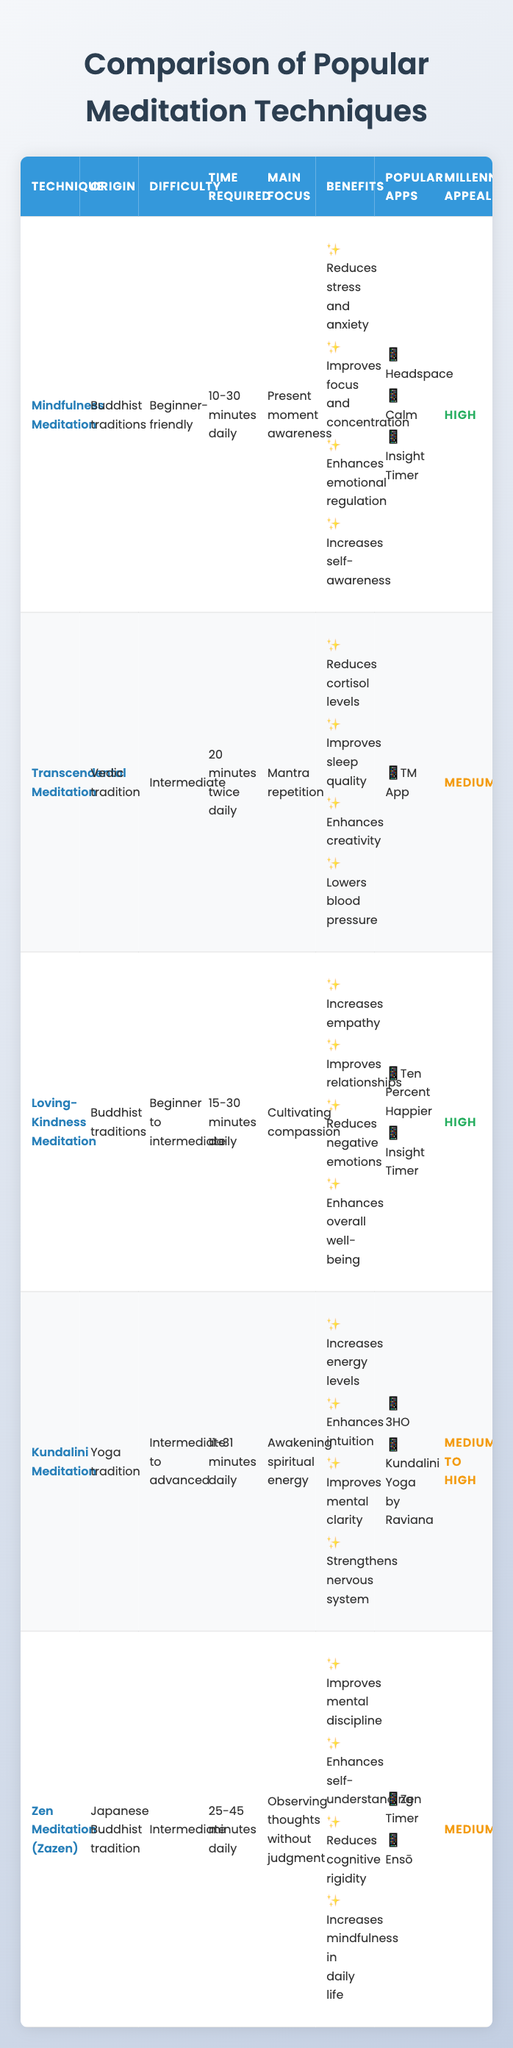What is the main focus of Zen Meditation? According to the table, Zen Meditation's main focus is observing thoughts without judgment. This information is directly listed under the "Main Focus" column for Zen Meditation.
Answer: Observing thoughts without judgment Which meditation technique is considered beginner-friendly? The table indicates that Mindfulness Meditation is categorized as beginner-friendly in the "Difficulty" column.
Answer: Mindfulness Meditation How many meditation techniques have a high appeal to millennials? In the table, both Mindfulness Meditation and Loving-Kindness Meditation have a "High" appeal rating, leading to the conclusion that there are 2 techniques appealing to millennials.
Answer: 2 Is it true that all meditation techniques require daily practice? Yes, the table states that every meditation technique lists a time required that is specified as daily in the "Time Required" column. This indicates that each technique indeed requires daily practice.
Answer: Yes What is the difference in time required between Transcendental Meditation and Kundalini Meditation? The time required for Transcendental Meditation is 20 minutes twice daily, which totals 40 minutes, while Kundalini Meditation requires 11 to 31 minutes daily. Taking the average of Kundalini Meditation gives about 21 minutes, and thus the difference between them is 40 - 21 = 19 minutes.
Answer: 19 minutes Which technique has the most benefits listed in the table? Upon examining the "Benefits" column for each technique listed in the table, all meditation techniques provide 4 benefits each. Therefore, no technique has more benefits than the others.
Answer: None What are the popular apps for Loving-Kindness Meditation? The table specifies that the popular apps for Loving-Kindness Meditation are Ten Percent Happier and Insight Timer, which is clearly listed in the "Popular Apps" column for that technique.
Answer: Ten Percent Happier, Insight Timer Which meditation technique has the lowest millennial appeal? By reviewing the "Millennial Appeal" column, Transcendental Meditation is categorized as "Medium," which is the lowest appeal compared to others that are either "High" or "Medium to high."
Answer: Transcendental Meditation What is the average time required for the meditation techniques that appeal to millennials? The time required is as follows: Mindfulness Meditation is 20 minutes, Loving-Kindness Meditation is 22.5 minutes (average of 15-30), and Kundalini Meditation is 21 minutes (average of 11-31). Calculating the sum: 20 + 22.5 + 21 = 63.5 minutes, and the average for three techniques is 63.5/3 = approximately 21.17 minutes.
Answer: Approximately 21.17 minutes 